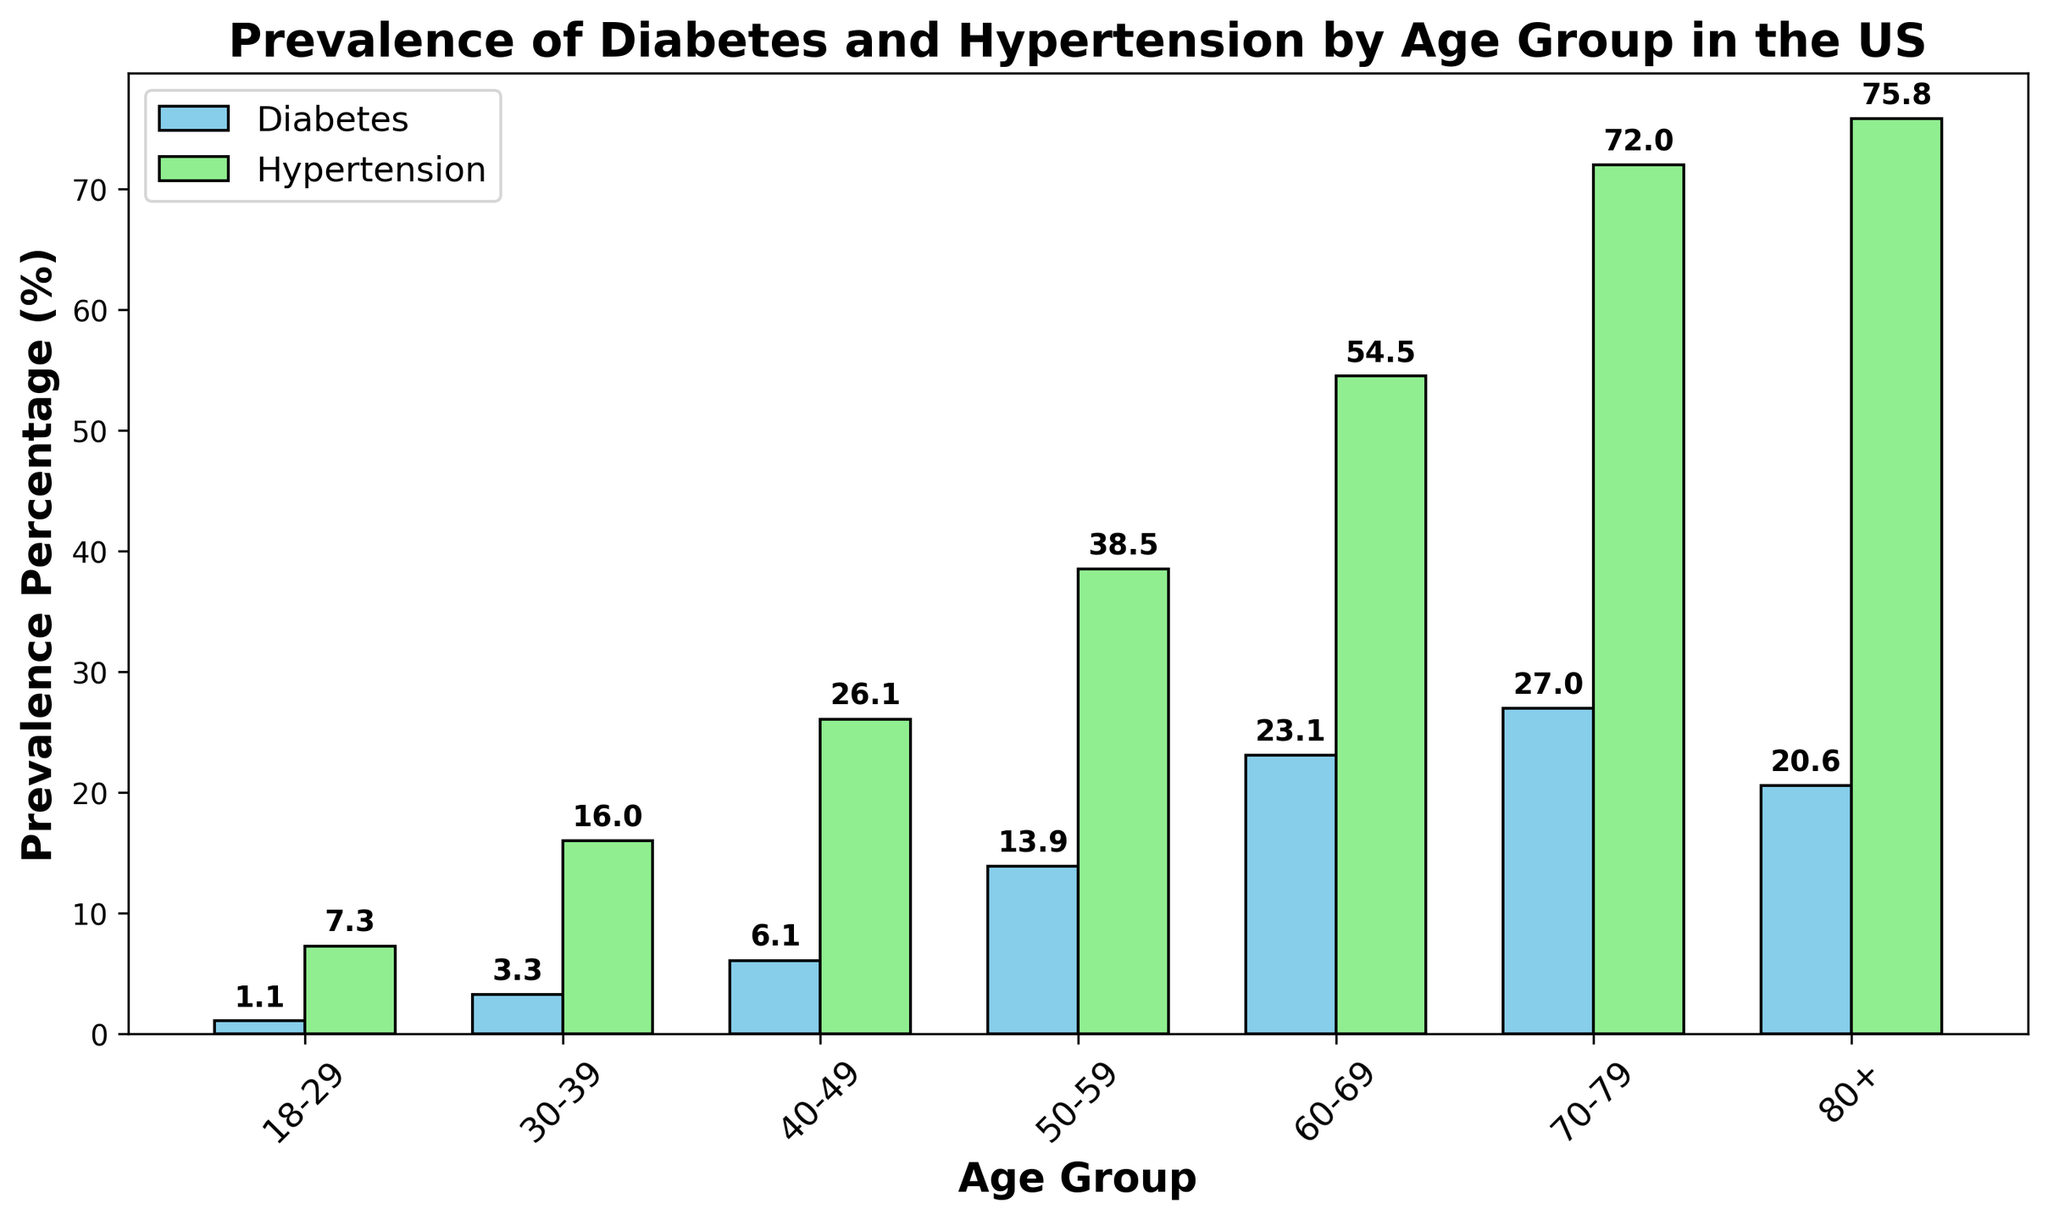What's the prevalence percentage of diabetes in the 50-59 age group? Look at the bar for the 50-59 age group in the diabetes category. The bar height indicates the prevalence percentage.
Answer: 13.9 Which age group has the highest prevalence of hypertension? Observe the height of the bars for each age group in the hypertension category. The tallest bar represents the age group with the highest prevalence.
Answer: 80+ How much greater is the prevalence of hypertension compared to diabetes in the 30-39 age group? Subtract the prevalence percentage of diabetes in the 30-39 age group from the prevalence percentage of hypertension in the same age group: (16.0 - 3.3).
Answer: 12.7 What is the difference in prevalence percentage of diabetes between the 40-49 and 70-79 age groups? Subtract the prevalence percentage of diabetes in the 40-49 age group from the prevalence percentage in the 70-79 age group: (27.0 - 6.1).
Answer: 20.9 What average prevalence percentage does the age group 60-69 have for diabetes and hypertension? Calculate the average by adding the prevalence percentages for diabetes and hypertension in the 60-69 age group and then dividing by 2: (23.1 + 54.5) / 2.
Answer: 38.8 Which disease has the highest prevalence in the 40-49 age group? Compare the height of the bars for diabetes and hypertension in the 40-49 age group. The taller bar indicates the disease with the higher prevalence.
Answer: Hypertension Is there any age group where the prevalence of diabetes is higher than hypertension? Review all the bars for both diabetes and hypertension across age groups. For each age group, check if the diabetes bar is taller than the hypertension bar.
Answer: No What is the cumulative prevalence percentage of hypertension in the age groups below 50? Add the prevalence percentages of hypertension for the age groups 18-29, 30-39, and 40-49: (7.3 + 16.0 + 26.1).
Answer: 49.4 By how much does the prevalence of hypertension increase from age group 18-29 to 80+? Subtract the prevalence percentage of hypertension in the 18-29 age group from the prevalence percentage in the 80+ age group: (75.8 - 7.3).
Answer: 68.5 Which age group shows a decline in diabetes prevalence from the previous age group, and by how much? Compare the prevalence percentages for diabetes across consecutive age groups to find the decline. The 80+ age group has a lower prevalence than the 70-79 age group. Subtract the 80+ percentage from the 70-79 percentage: (27.0 - 20.6).
Answer: 80+, 6.4 